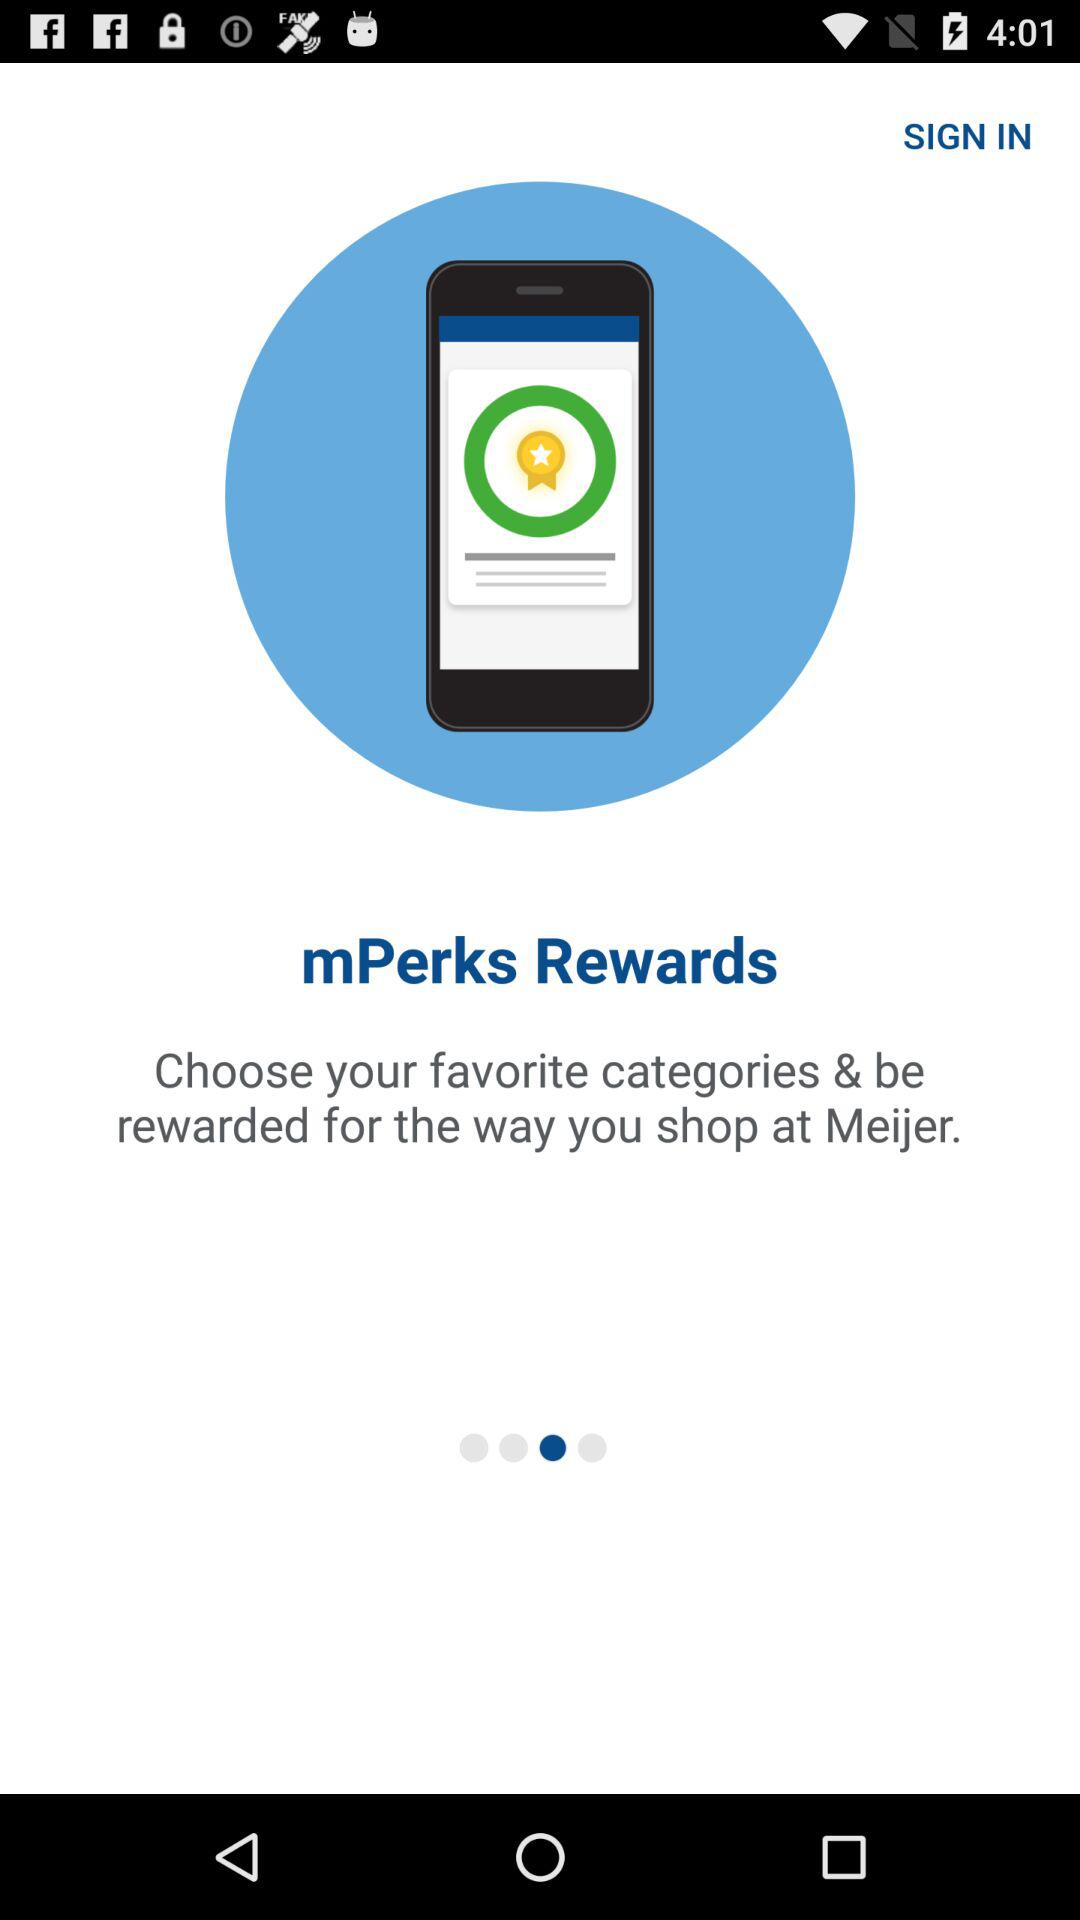What is the application name? The application name is "Meijer". 